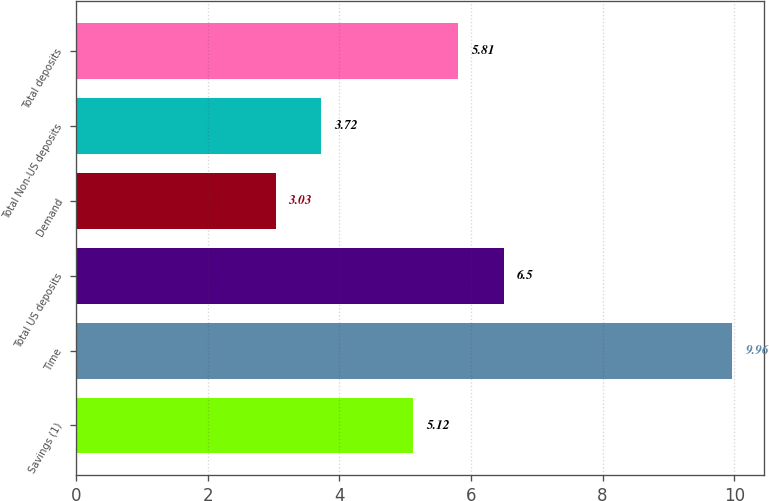Convert chart to OTSL. <chart><loc_0><loc_0><loc_500><loc_500><bar_chart><fcel>Savings (1)<fcel>Time<fcel>Total US deposits<fcel>Demand<fcel>Total Non-US deposits<fcel>Total deposits<nl><fcel>5.12<fcel>9.96<fcel>6.5<fcel>3.03<fcel>3.72<fcel>5.81<nl></chart> 